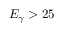Convert formula to latex. <formula><loc_0><loc_0><loc_500><loc_500>E _ { \gamma } > 2 5</formula> 